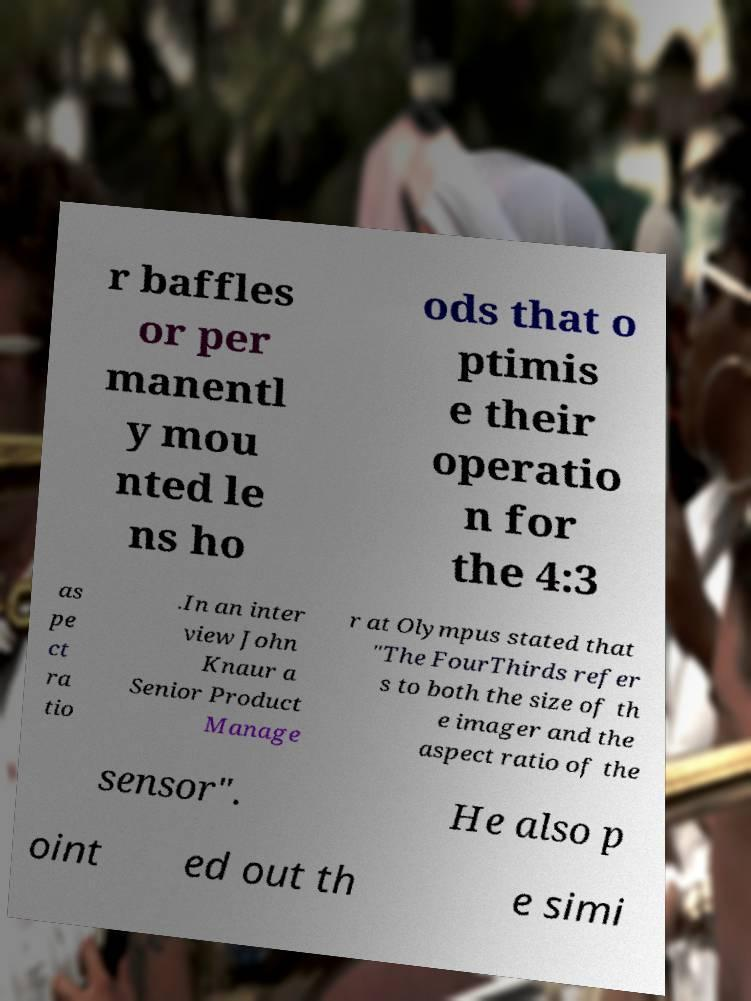Can you read and provide the text displayed in the image?This photo seems to have some interesting text. Can you extract and type it out for me? r baffles or per manentl y mou nted le ns ho ods that o ptimis e their operatio n for the 4:3 as pe ct ra tio .In an inter view John Knaur a Senior Product Manage r at Olympus stated that "The FourThirds refer s to both the size of th e imager and the aspect ratio of the sensor". He also p oint ed out th e simi 